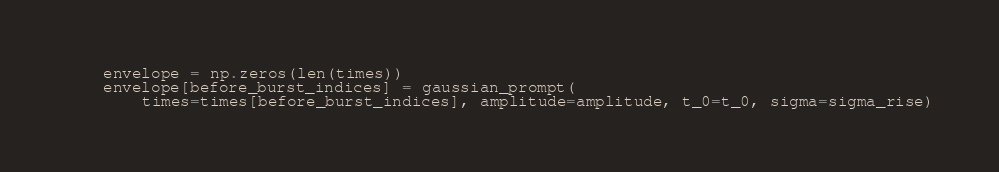Convert code to text. <code><loc_0><loc_0><loc_500><loc_500><_Python_>    envelope = np.zeros(len(times))
    envelope[before_burst_indices] = gaussian_prompt(
        times=times[before_burst_indices], amplitude=amplitude, t_0=t_0, sigma=sigma_rise)</code> 